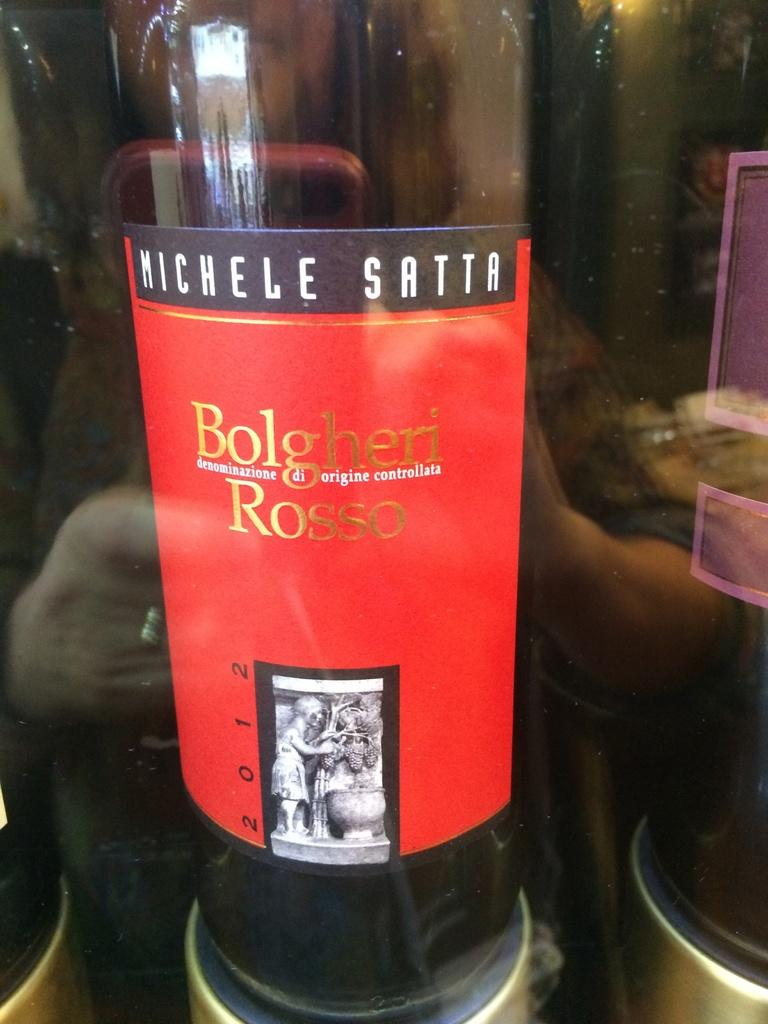<image>
Present a compact description of the photo's key features. Mostly empty bottle of Michelle Satta Bolgheri Rosso wine from 2012. 